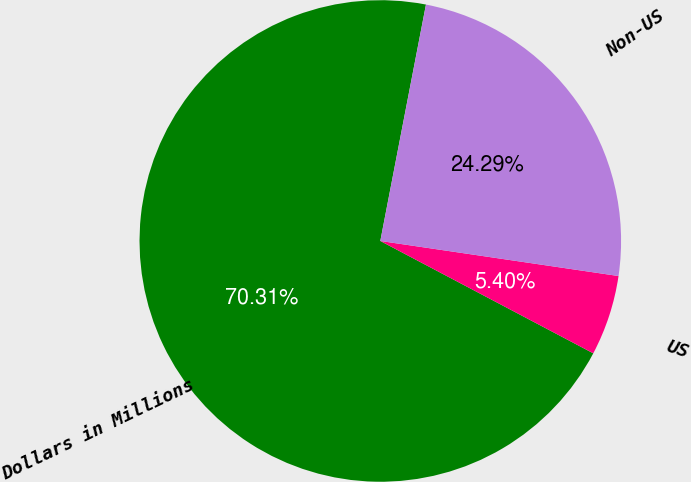<chart> <loc_0><loc_0><loc_500><loc_500><pie_chart><fcel>Dollars in Millions<fcel>US<fcel>Non-US<nl><fcel>70.31%<fcel>5.4%<fcel>24.29%<nl></chart> 